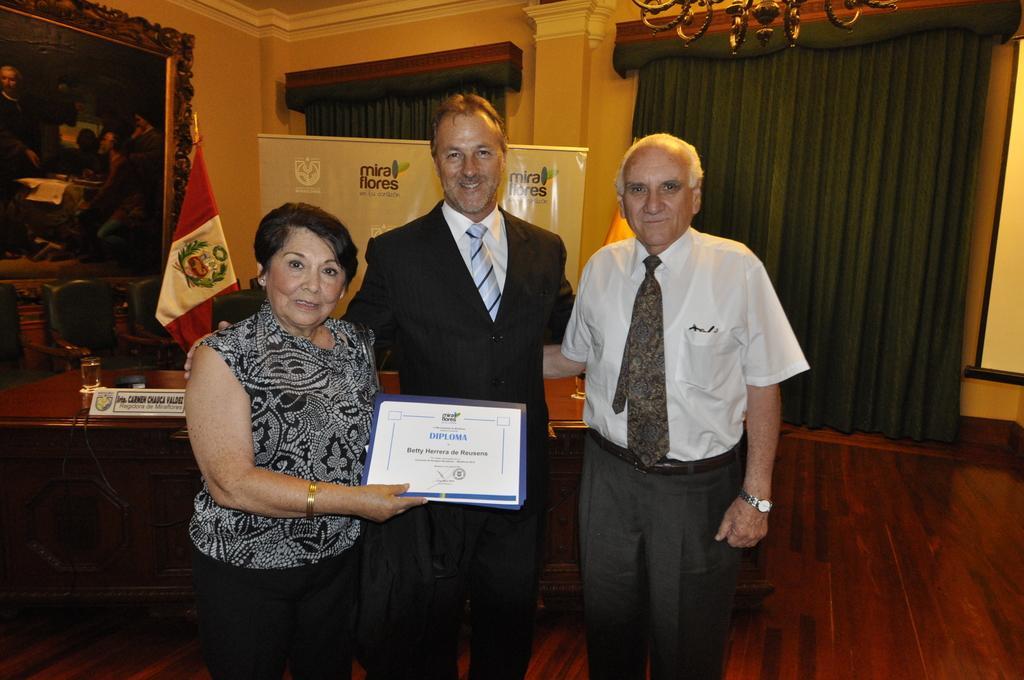In one or two sentences, can you explain what this image depicts? In this picture we can see two men and a woman, she is holding a certificate, in the background we can see a glass, name board and other things on the table, and also we can find a flag, chairs, curtains and a hoarding, and also we can see a frame on the wall. 